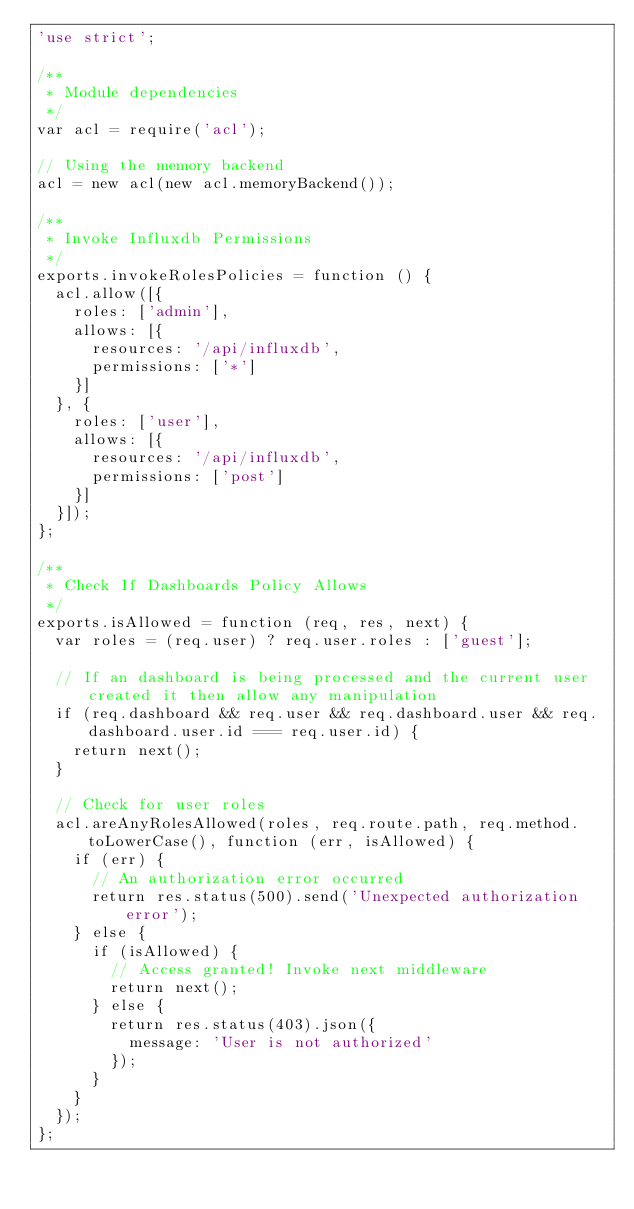<code> <loc_0><loc_0><loc_500><loc_500><_JavaScript_>'use strict';

/**
 * Module dependencies
 */
var acl = require('acl');

// Using the memory backend
acl = new acl(new acl.memoryBackend());

/**
 * Invoke Influxdb Permissions
 */
exports.invokeRolesPolicies = function () {
  acl.allow([{
    roles: ['admin'],
    allows: [{
      resources: '/api/influxdb',
      permissions: ['*']
    }]
  }, {
    roles: ['user'],
    allows: [{
      resources: '/api/influxdb',
      permissions: ['post']
    }]
  }]);
};

/**
 * Check If Dashboards Policy Allows
 */
exports.isAllowed = function (req, res, next) {
  var roles = (req.user) ? req.user.roles : ['guest'];

  // If an dashboard is being processed and the current user created it then allow any manipulation
  if (req.dashboard && req.user && req.dashboard.user && req.dashboard.user.id === req.user.id) {
    return next();
  }

  // Check for user roles
  acl.areAnyRolesAllowed(roles, req.route.path, req.method.toLowerCase(), function (err, isAllowed) {
    if (err) {
      // An authorization error occurred
      return res.status(500).send('Unexpected authorization error');
    } else {
      if (isAllowed) {
        // Access granted! Invoke next middleware
        return next();
      } else {
        return res.status(403).json({
          message: 'User is not authorized'
        });
      }
    }
  });
};
</code> 